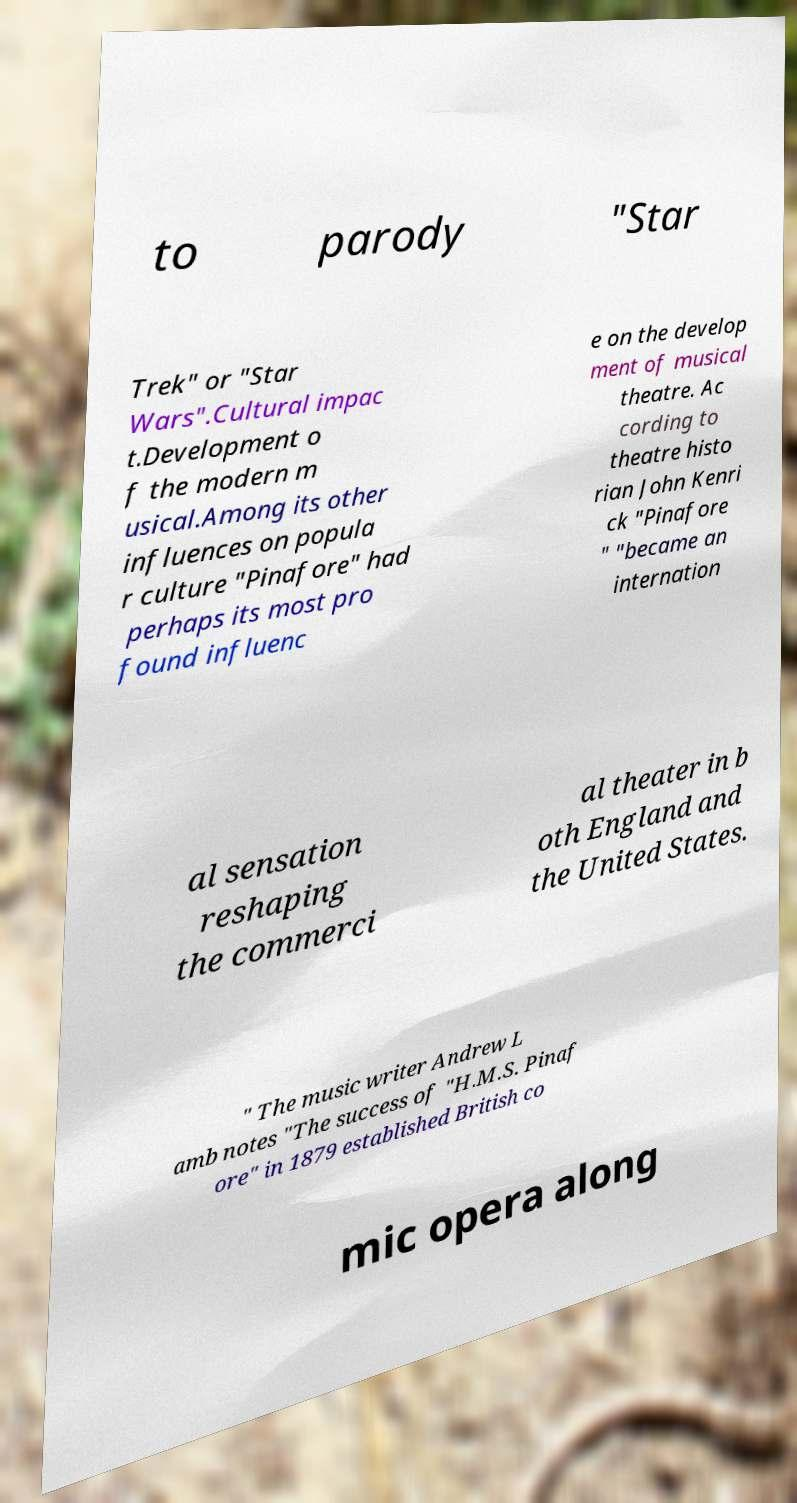What messages or text are displayed in this image? I need them in a readable, typed format. to parody "Star Trek" or "Star Wars".Cultural impac t.Development o f the modern m usical.Among its other influences on popula r culture "Pinafore" had perhaps its most pro found influenc e on the develop ment of musical theatre. Ac cording to theatre histo rian John Kenri ck "Pinafore " "became an internation al sensation reshaping the commerci al theater in b oth England and the United States. " The music writer Andrew L amb notes "The success of "H.M.S. Pinaf ore" in 1879 established British co mic opera along 